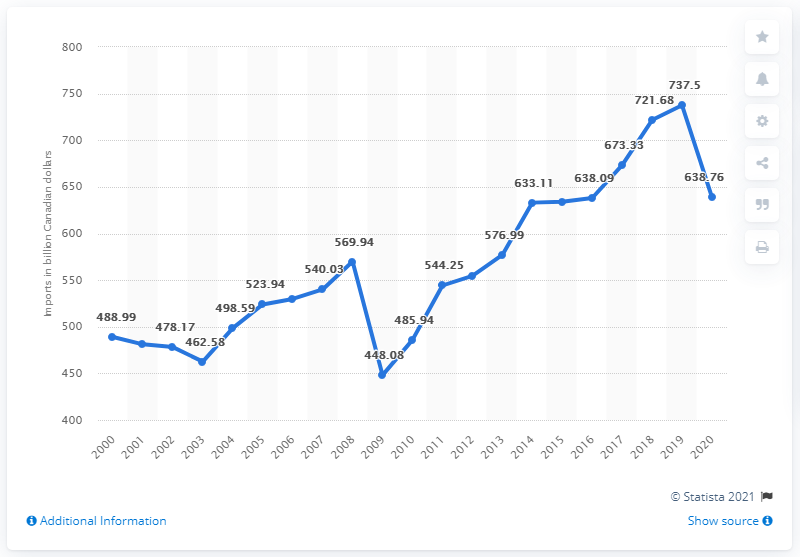Specify some key components in this picture. The total amount of imports of trade goods and services in the previous year was 737.5. In 2020, Canada imported goods and services to the value of CAD 638.76 billion. 